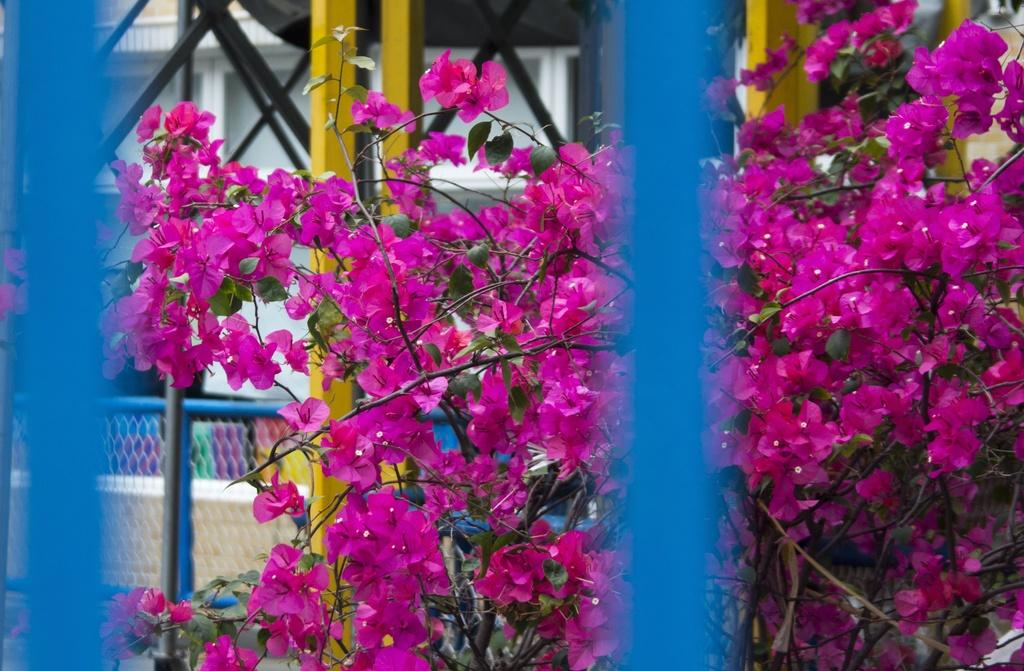What type of flowers are present in the image? There are pink flowers in the image. Can you describe the structure of the flowers? The flowers have stems and leaves. What color is present in the image besides the pink flowers? There are blue color things in the image. What architectural elements can be seen in the background of the image? There are rods, a mesh, pillars, railing, and a wall in the background of the image. What type of books can be seen in the library in the image? There is no library or books present in the image; it features pink flowers, blue color things, and various architectural elements in the background. How many attempts were made to break the vase in the image? There is no vase or attempt to break it present in the image. 